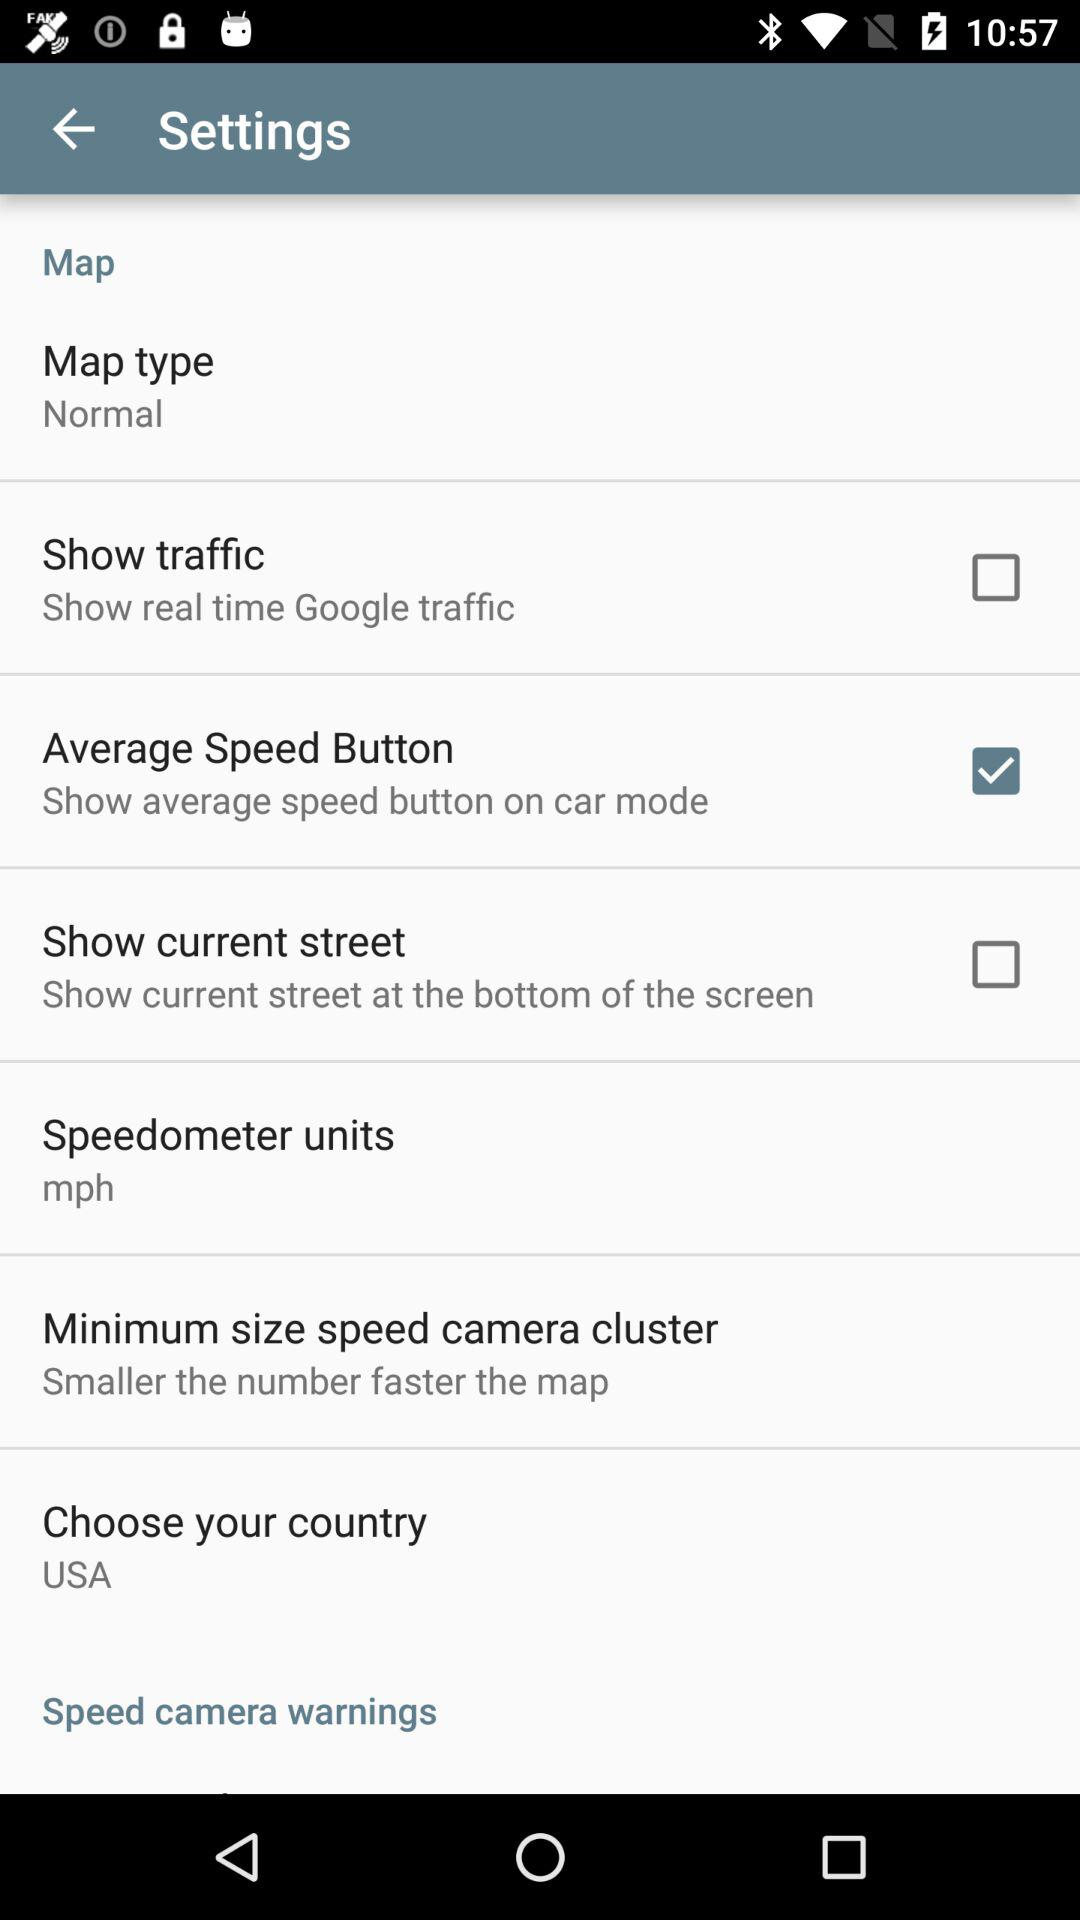What is the chosen country? The chosen country is the USA. 